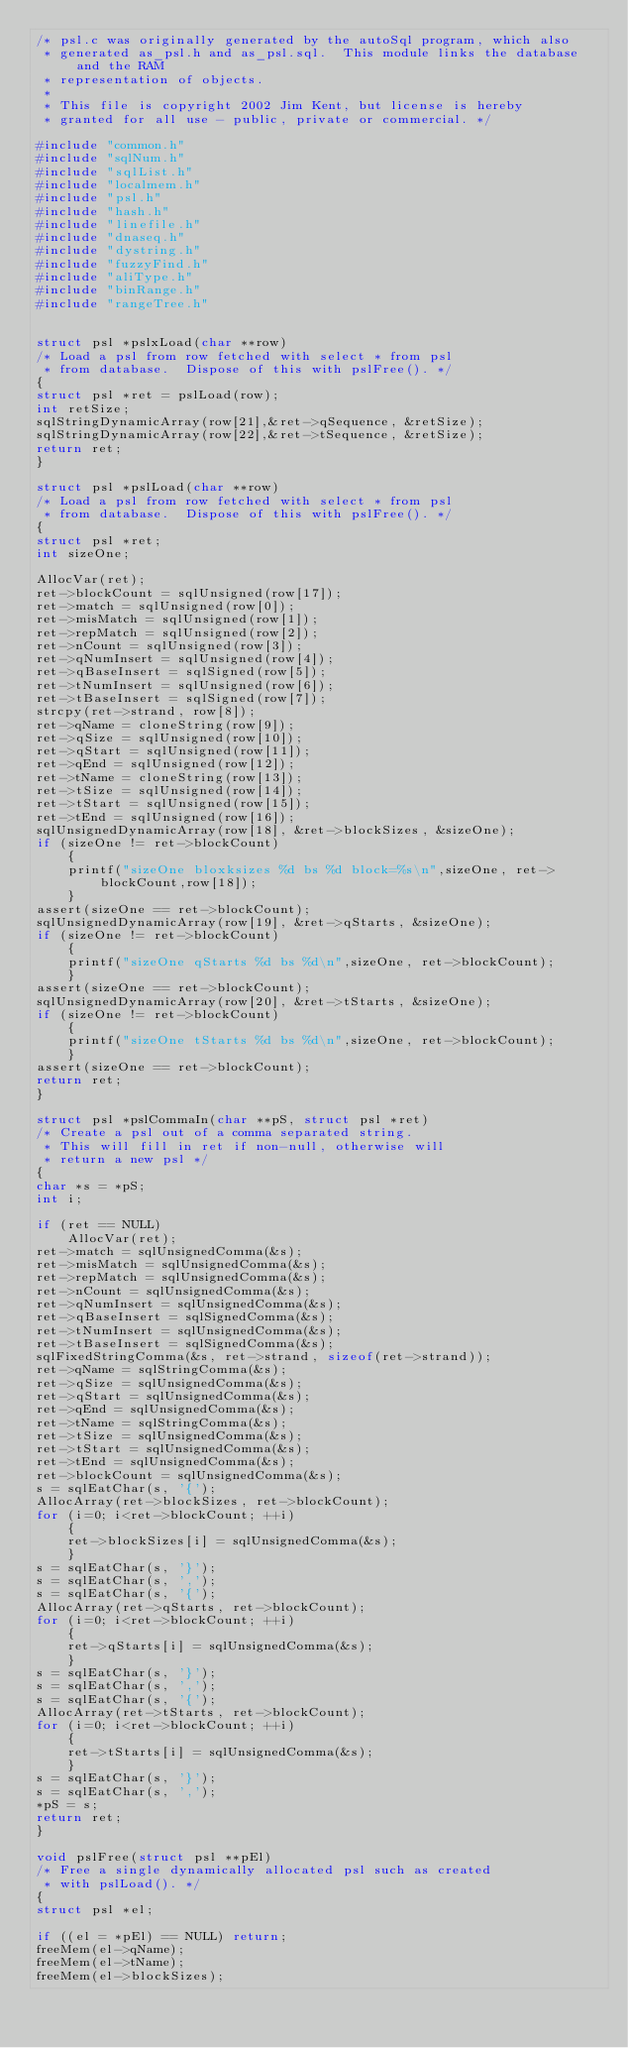<code> <loc_0><loc_0><loc_500><loc_500><_C_>/* psl.c was originally generated by the autoSql program, which also 
 * generated as_psl.h and as_psl.sql.  This module links the database and the RAM 
 * representation of objects. 
 *
 * This file is copyright 2002 Jim Kent, but license is hereby
 * granted for all use - public, private or commercial. */

#include "common.h"
#include "sqlNum.h"
#include "sqlList.h"
#include "localmem.h"
#include "psl.h"
#include "hash.h"
#include "linefile.h"
#include "dnaseq.h"
#include "dystring.h"
#include "fuzzyFind.h"
#include "aliType.h"
#include "binRange.h"
#include "rangeTree.h"


struct psl *pslxLoad(char **row)
/* Load a psl from row fetched with select * from psl
 * from database.  Dispose of this with pslFree(). */
{
struct psl *ret = pslLoad(row);
int retSize;
sqlStringDynamicArray(row[21],&ret->qSequence, &retSize);
sqlStringDynamicArray(row[22],&ret->tSequence, &retSize);
return ret;
}

struct psl *pslLoad(char **row)
/* Load a psl from row fetched with select * from psl
 * from database.  Dispose of this with pslFree(). */
{
struct psl *ret;
int sizeOne;

AllocVar(ret);
ret->blockCount = sqlUnsigned(row[17]);
ret->match = sqlUnsigned(row[0]);
ret->misMatch = sqlUnsigned(row[1]);
ret->repMatch = sqlUnsigned(row[2]);
ret->nCount = sqlUnsigned(row[3]);
ret->qNumInsert = sqlUnsigned(row[4]);
ret->qBaseInsert = sqlSigned(row[5]);
ret->tNumInsert = sqlUnsigned(row[6]);
ret->tBaseInsert = sqlSigned(row[7]);
strcpy(ret->strand, row[8]);
ret->qName = cloneString(row[9]);
ret->qSize = sqlUnsigned(row[10]);
ret->qStart = sqlUnsigned(row[11]);
ret->qEnd = sqlUnsigned(row[12]);
ret->tName = cloneString(row[13]);
ret->tSize = sqlUnsigned(row[14]);
ret->tStart = sqlUnsigned(row[15]);
ret->tEnd = sqlUnsigned(row[16]);
sqlUnsignedDynamicArray(row[18], &ret->blockSizes, &sizeOne);
if (sizeOne != ret->blockCount)
    {
    printf("sizeOne bloxksizes %d bs %d block=%s\n",sizeOne, ret->blockCount,row[18]);
    }
assert(sizeOne == ret->blockCount);
sqlUnsignedDynamicArray(row[19], &ret->qStarts, &sizeOne);
if (sizeOne != ret->blockCount)
    {
    printf("sizeOne qStarts %d bs %d\n",sizeOne, ret->blockCount);
    }
assert(sizeOne == ret->blockCount);
sqlUnsignedDynamicArray(row[20], &ret->tStarts, &sizeOne);
if (sizeOne != ret->blockCount)
    {
    printf("sizeOne tStarts %d bs %d\n",sizeOne, ret->blockCount);
    }
assert(sizeOne == ret->blockCount);
return ret;
}

struct psl *pslCommaIn(char **pS, struct psl *ret)
/* Create a psl out of a comma separated string. 
 * This will fill in ret if non-null, otherwise will
 * return a new psl */
{
char *s = *pS;
int i;

if (ret == NULL)
    AllocVar(ret);
ret->match = sqlUnsignedComma(&s);
ret->misMatch = sqlUnsignedComma(&s);
ret->repMatch = sqlUnsignedComma(&s);
ret->nCount = sqlUnsignedComma(&s);
ret->qNumInsert = sqlUnsignedComma(&s);
ret->qBaseInsert = sqlSignedComma(&s);
ret->tNumInsert = sqlUnsignedComma(&s);
ret->tBaseInsert = sqlSignedComma(&s);
sqlFixedStringComma(&s, ret->strand, sizeof(ret->strand));
ret->qName = sqlStringComma(&s);
ret->qSize = sqlUnsignedComma(&s);
ret->qStart = sqlUnsignedComma(&s);
ret->qEnd = sqlUnsignedComma(&s);
ret->tName = sqlStringComma(&s);
ret->tSize = sqlUnsignedComma(&s);
ret->tStart = sqlUnsignedComma(&s);
ret->tEnd = sqlUnsignedComma(&s);
ret->blockCount = sqlUnsignedComma(&s);
s = sqlEatChar(s, '{');
AllocArray(ret->blockSizes, ret->blockCount);
for (i=0; i<ret->blockCount; ++i)
    {
    ret->blockSizes[i] = sqlUnsignedComma(&s);
    }
s = sqlEatChar(s, '}');
s = sqlEatChar(s, ',');
s = sqlEatChar(s, '{');
AllocArray(ret->qStarts, ret->blockCount);
for (i=0; i<ret->blockCount; ++i)
    {
    ret->qStarts[i] = sqlUnsignedComma(&s);
    }
s = sqlEatChar(s, '}');
s = sqlEatChar(s, ',');
s = sqlEatChar(s, '{');
AllocArray(ret->tStarts, ret->blockCount);
for (i=0; i<ret->blockCount; ++i)
    {
    ret->tStarts[i] = sqlUnsignedComma(&s);
    }
s = sqlEatChar(s, '}');
s = sqlEatChar(s, ',');
*pS = s;
return ret;
}

void pslFree(struct psl **pEl)
/* Free a single dynamically allocated psl such as created
 * with pslLoad(). */
{
struct psl *el;

if ((el = *pEl) == NULL) return;
freeMem(el->qName);
freeMem(el->tName);
freeMem(el->blockSizes);</code> 